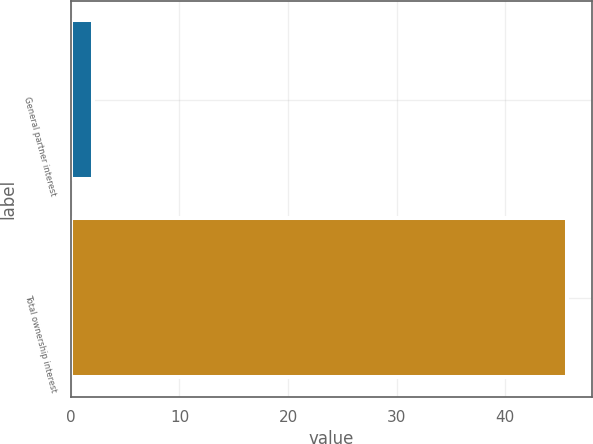Convert chart. <chart><loc_0><loc_0><loc_500><loc_500><bar_chart><fcel>General partner interest<fcel>Total ownership interest<nl><fcel>2<fcel>45.7<nl></chart> 